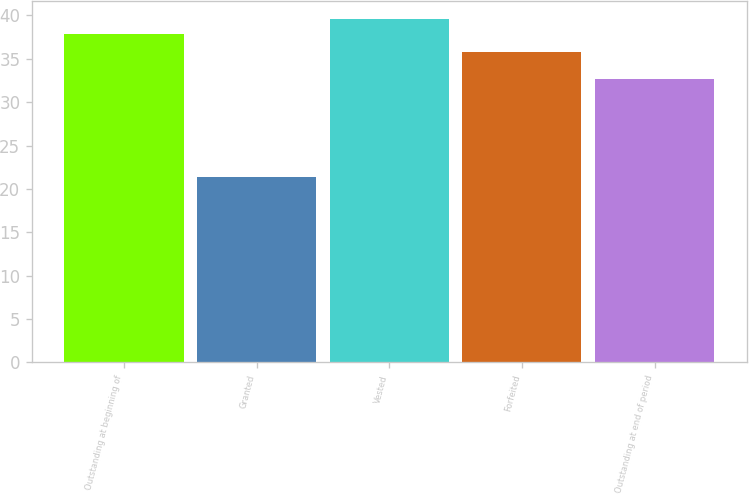<chart> <loc_0><loc_0><loc_500><loc_500><bar_chart><fcel>Outstanding at beginning of<fcel>Granted<fcel>Vested<fcel>Forfeited<fcel>Outstanding at end of period<nl><fcel>37.91<fcel>21.36<fcel>39.63<fcel>35.74<fcel>32.72<nl></chart> 